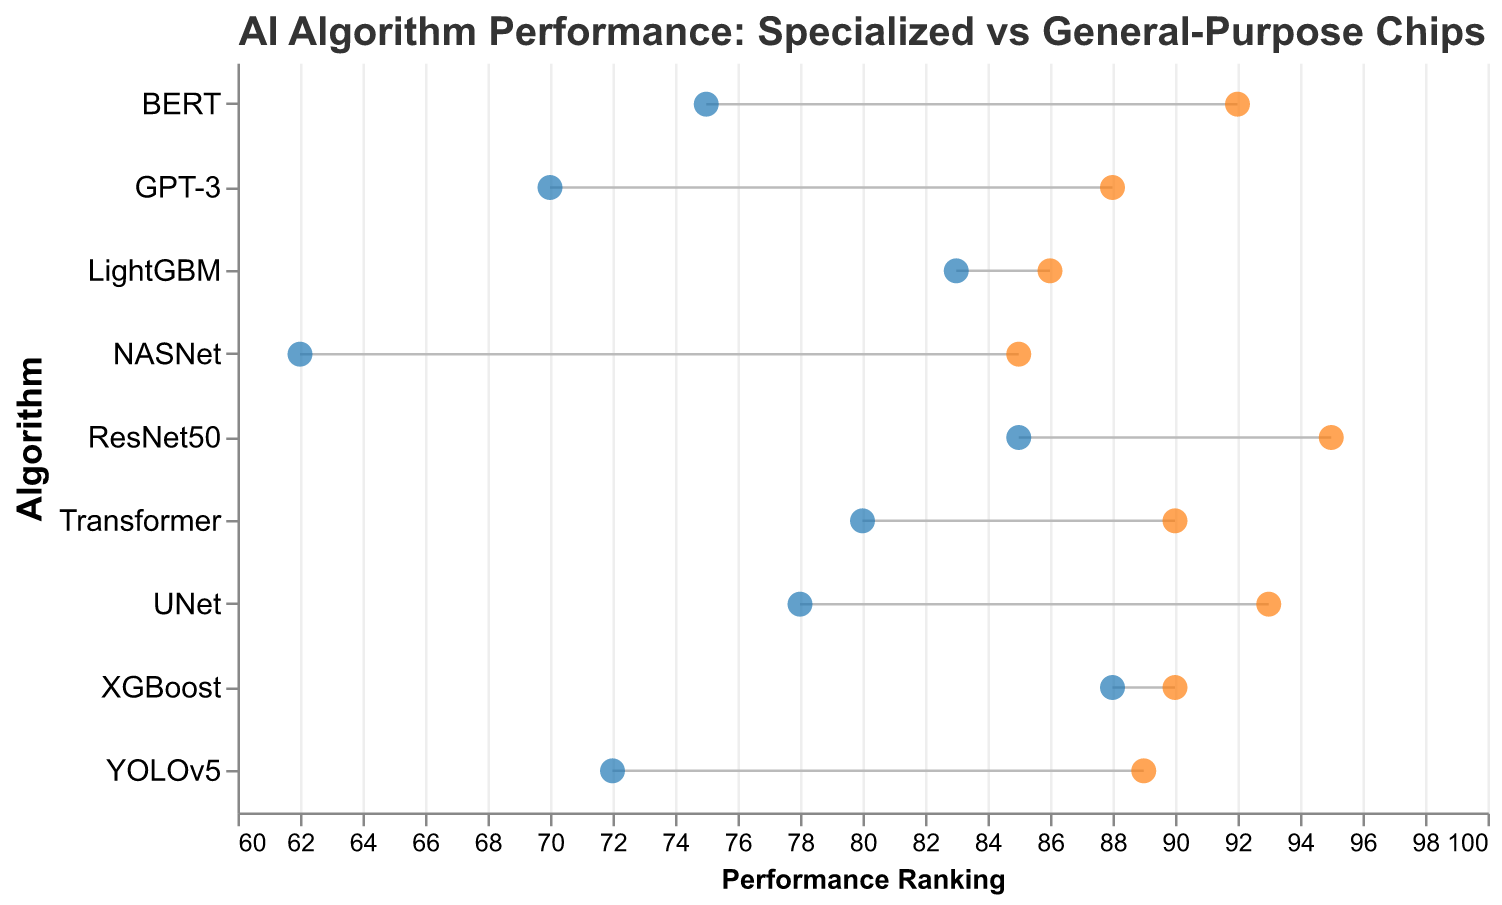What is the title of the figure? The title is displayed at the top of the figure and helps describe what the plot is showing.
Answer: AI Algorithm Performance: Specialized vs General-Purpose Chips Which AI algorithm shows the largest improvement in performance when using specialized chips compared to general-purpose chips? By visually comparing the difference between the two points for each algorithm, BERT shows the most significant improvement (92 - 75 = 17).
Answer: BERT What is the performance ranking of GPT-3 on specialized chips? Locate GPT-3 on the y-axis and see where the orange point (specialized chip ranking) is positioned on the x-axis, which corresponds to 88.
Answer: 88 Which algorithm has the smallest performance difference between specialized and general-purpose chips? By examining the lengths of the connecting lines, XGBoost shows the smallest difference since both points are close to each other (90 - 88 = 2).
Answer: XGBoost List all algorithms that have a performance ranking of 90 or higher on specialized chips. Identify the orange points that are at or above the 90 mark on the x-axis: ResNet50 (95), Transformer (90), BERT (92), UNet (93), and XGBoost (90).
Answer: ResNet50, Transformer, BERT, UNet, XGBoost What is the average performance ranking of LightGBM across both types of chips? Calculate the average by adding the rankings on both types of chips and dividing by 2 ((83 + 86) / 2 = 84.5).
Answer: 84.5 How many AI algorithms are included in the figure? Count the number of unique algorithms listed on the y-axis. There are 9 algorithms in total.
Answer: 9 Which algorithm shows better performance on general-purpose chips than on specialized chips? Look for algorithms where the blue points are to the right of the orange points. None of the algorithms have this pattern.
Answer: None What is the performance improvement for YOLOv5 on specialized chips compared to general-purpose chips? Calculate the difference in performance rankings between specialized and general-purpose chips for YOLOv5 (89 - 72 = 17).
Answer: 17 Which algorithm has a performance ranking of 78 on general-purpose chips? Locate the blue point positioned at 78 on the x-axis and find the corresponding algorithm: UNet.
Answer: UNet 